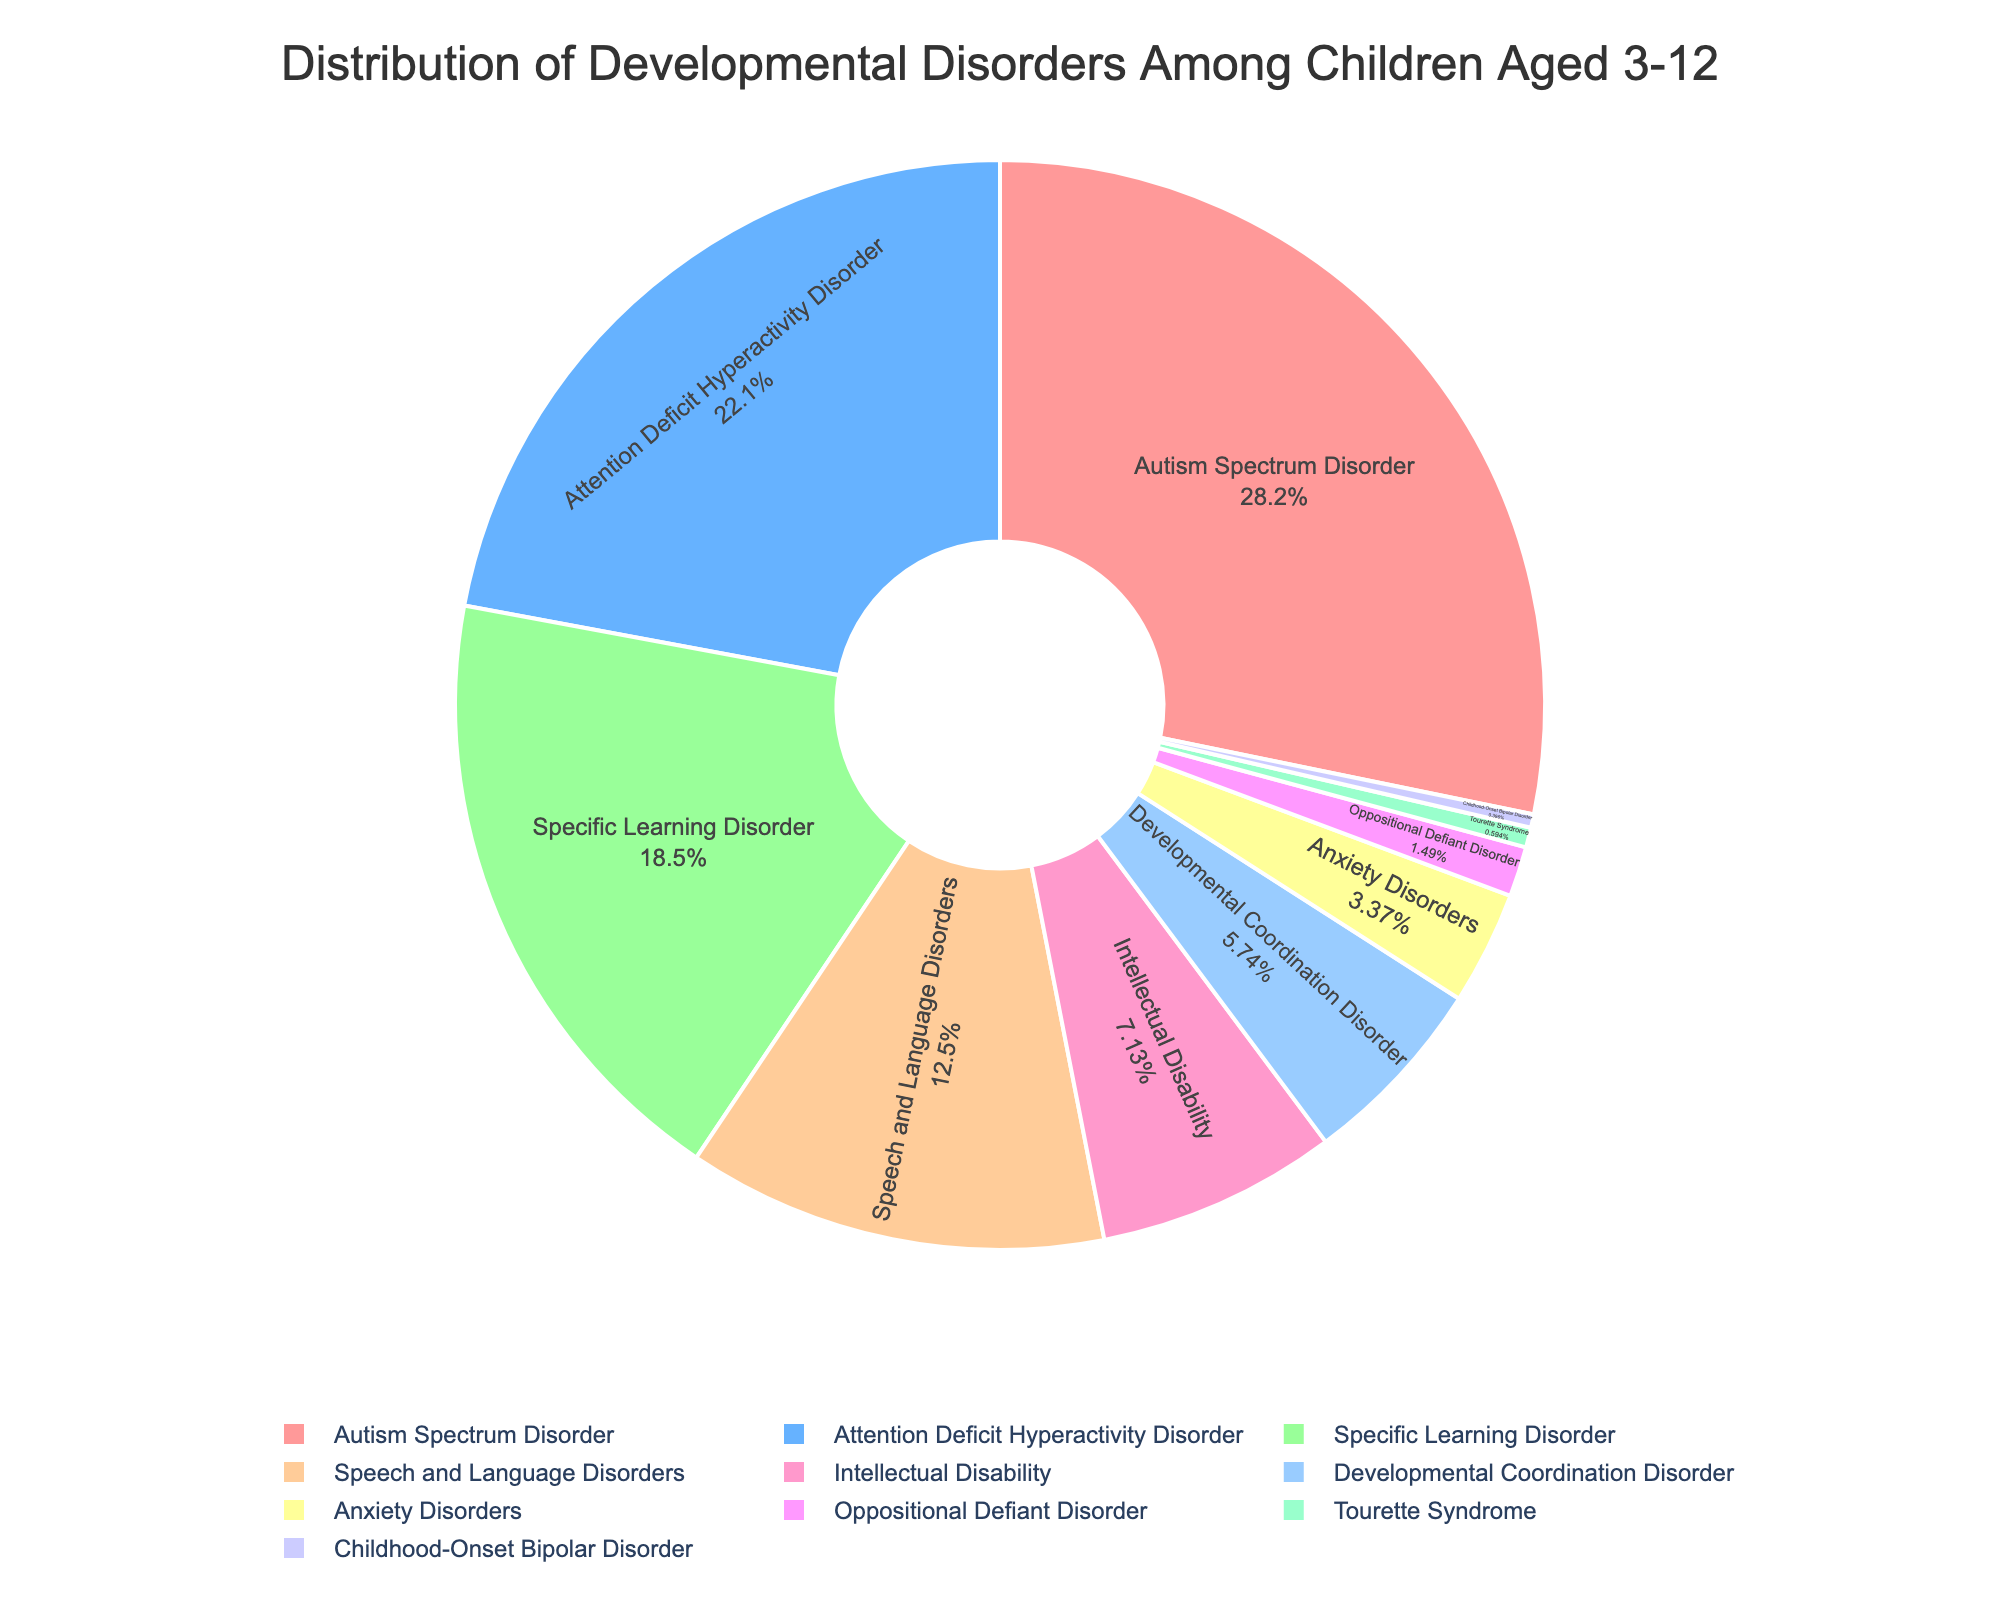What is the most common developmental disorder among children aged 3-12? To find the most common disorder, look for the segment with the largest percentage. Autism Spectrum Disorder has the largest percentage at 28.5%.
Answer: Autism Spectrum Disorder Which disorder has a percentage closest to 20%? To determine the disorder closest to 20%, compare the percentages of all disorders. Attention Deficit Hyperactivity Disorder is the closest at 22.3%.
Answer: Attention Deficit Hyperactivity Disorder Which two disorders combined make up more than 40% of the total? Identify two disorders whose summed percentage exceeds 40%. Autism Spectrum Disorder (28.5%) and Attention Deficit Hyperactivity Disorder (22.3%) together make up 50.8%.
Answer: Autism Spectrum Disorder and Attention Deficit Hyperactivity Disorder How much more common is Autism Spectrum Disorder compared to Specific Learning Disorder? Subtract the percentage of Specific Learning Disorder from Autism Spectrum Disorder: 28.5% - 18.7% = 9.8%.
Answer: 9.8% What is the sum of the percentages for Speech and Language Disorders, Intellectual Disability, and Developmental Coordination Disorder? Add the percentages of the specified disorders: 12.6% + 7.2% + 5.8% = 25.6%.
Answer: 25.6% Which disorder has the smallest percentage? To find the least common disorder, look for the segment with the smallest percentage. Childhood-Onset Bipolar Disorder has the smallest at 0.4%.
Answer: Childhood-Onset Bipolar Disorder Is Attention Deficit Hyperactivity Disorder more common than Specific Learning Disorder? If so, by how much? Compare the percentages of the two disorders. Attention Deficit Hyperactivity Disorder (22.3%) is more common than Specific Learning Disorder (18.7%). Calculate the difference: 22.3% - 18.7% = 3.6%.
Answer: Yes, by 3.6% What percentage of children have either Autism Spectrum Disorder or an Anxiety Disorder? Add the percentages of Autism Spectrum Disorder and Anxiety Disorders: 28.5% + 3.4% = 31.9%.
Answer: 31.9% If you combined the percentages of Intellectual Disability, Developmental Coordination Disorder, and Oppositional Defiant Disorder, would their total exceed 15%? Add the percentages of the three disorders and compare to 15%: 7.2% + 5.8% + 1.5% = 14.5%, which does not exceed 15%.
Answer: No, 14.5% What is the difference in percentages between Speech and Language Disorders and Tourette Syndrome? Subtract the percentage of Tourette Syndrome from Speech and Language Disorders: 12.6% - 0.6% = 12%.
Answer: 12% 